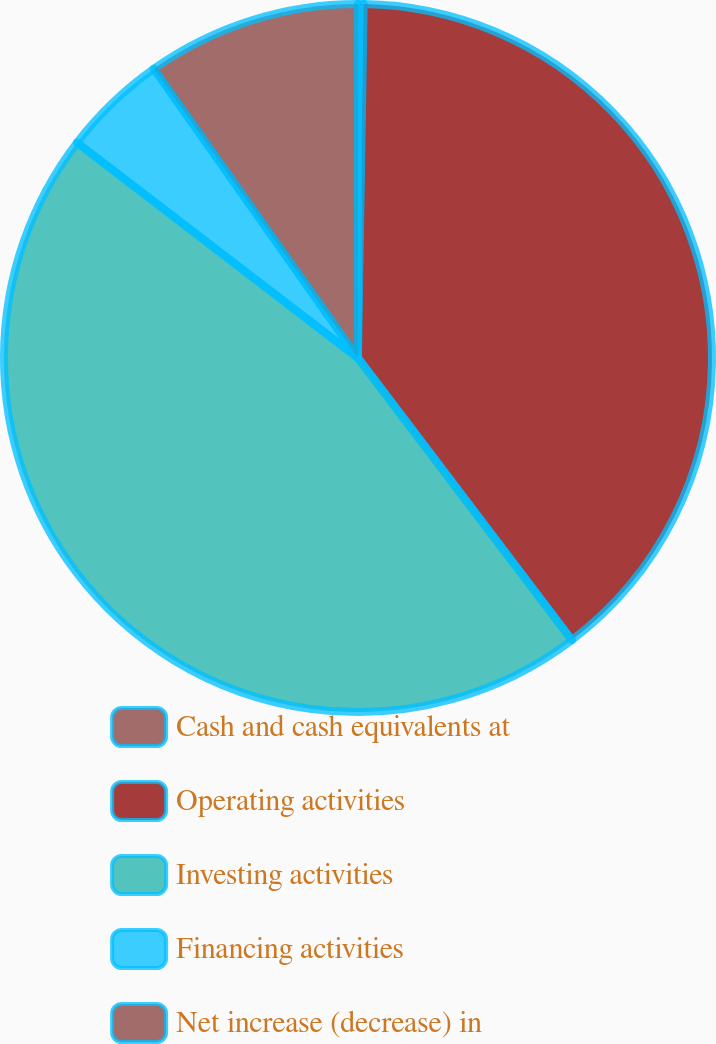Convert chart. <chart><loc_0><loc_0><loc_500><loc_500><pie_chart><fcel>Cash and cash equivalents at<fcel>Operating activities<fcel>Investing activities<fcel>Financing activities<fcel>Net increase (decrease) in<nl><fcel>0.26%<fcel>39.41%<fcel>45.73%<fcel>4.81%<fcel>9.78%<nl></chart> 